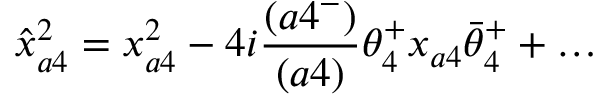<formula> <loc_0><loc_0><loc_500><loc_500>\hat { x } _ { a 4 } ^ { 2 } = x _ { a 4 } ^ { 2 } - 4 i { \frac { ( a 4 ^ { - } ) } { ( a 4 ) } } \theta _ { 4 } ^ { + } x _ { a 4 } \bar { \theta } _ { 4 } ^ { + } + \dots</formula> 